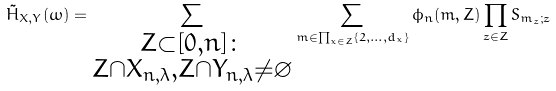<formula> <loc_0><loc_0><loc_500><loc_500>\tilde { H } _ { X , Y } ( \omega ) = \sum _ { \substack { Z \subset [ 0 , n ] \colon \\ Z \cap X _ { n , \lambda } , Z \cap Y _ { n , \lambda } \neq \varnothing } } \sum _ { { m } \in \prod _ { x \in Z } \{ 2 , \dots , d _ { x } \} } \phi _ { n } ( { m } , Z ) \prod _ { z \in Z } S _ { { m } _ { z } ; z }</formula> 